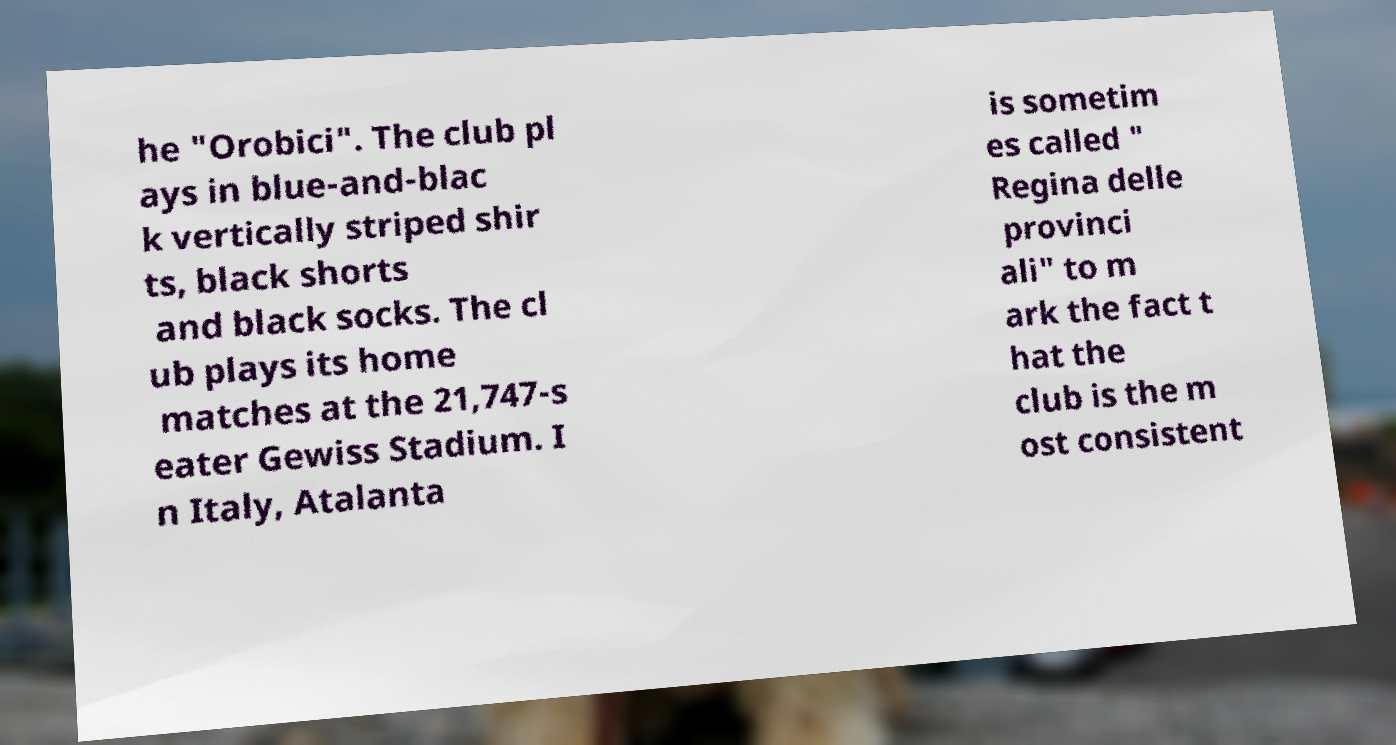Please read and relay the text visible in this image. What does it say? he "Orobici". The club pl ays in blue-and-blac k vertically striped shir ts, black shorts and black socks. The cl ub plays its home matches at the 21,747-s eater Gewiss Stadium. I n Italy, Atalanta is sometim es called " Regina delle provinci ali" to m ark the fact t hat the club is the m ost consistent 